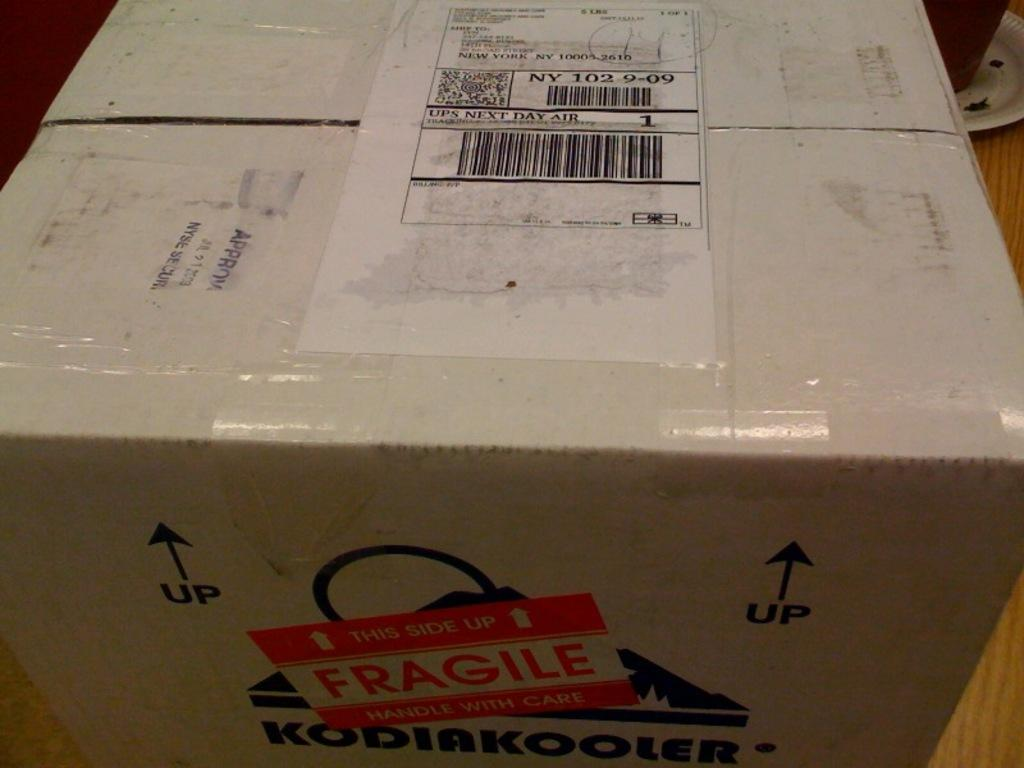<image>
Provide a brief description of the given image. A package has a UPS Next Day Air sticker on the top. 